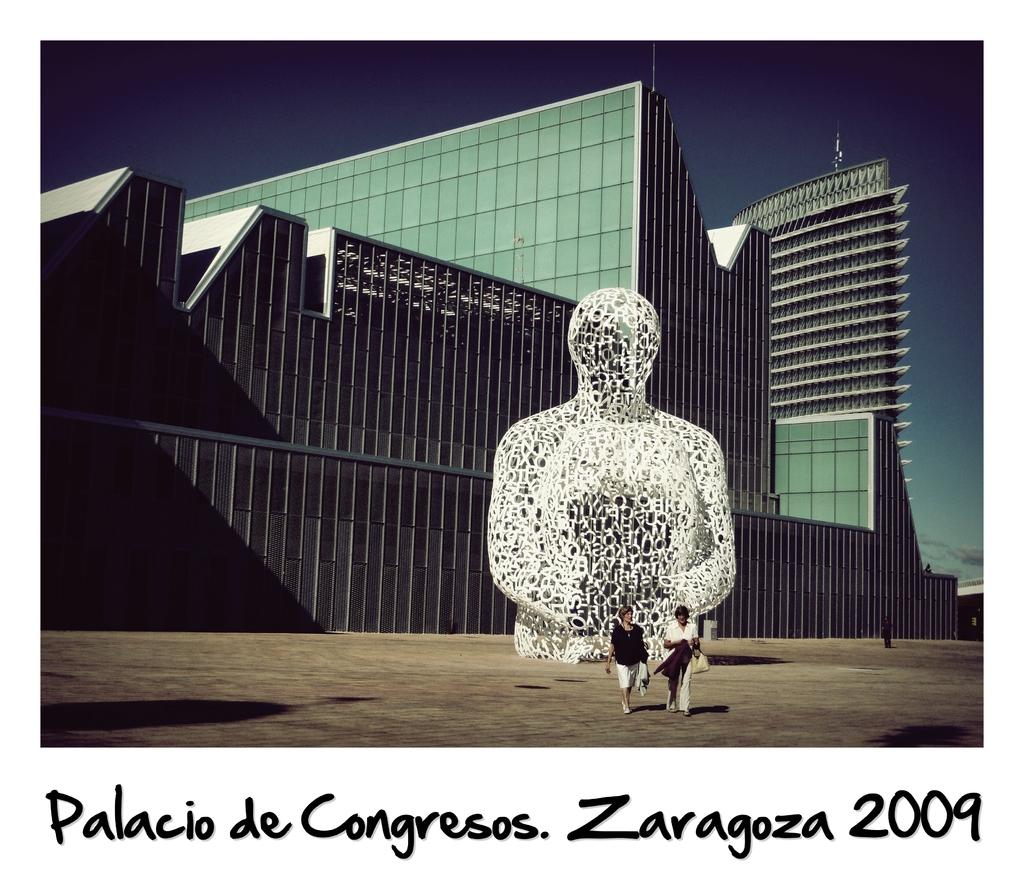What year was the photo taken?
Your response must be concise. 2009. 